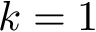Convert formula to latex. <formula><loc_0><loc_0><loc_500><loc_500>k = 1</formula> 